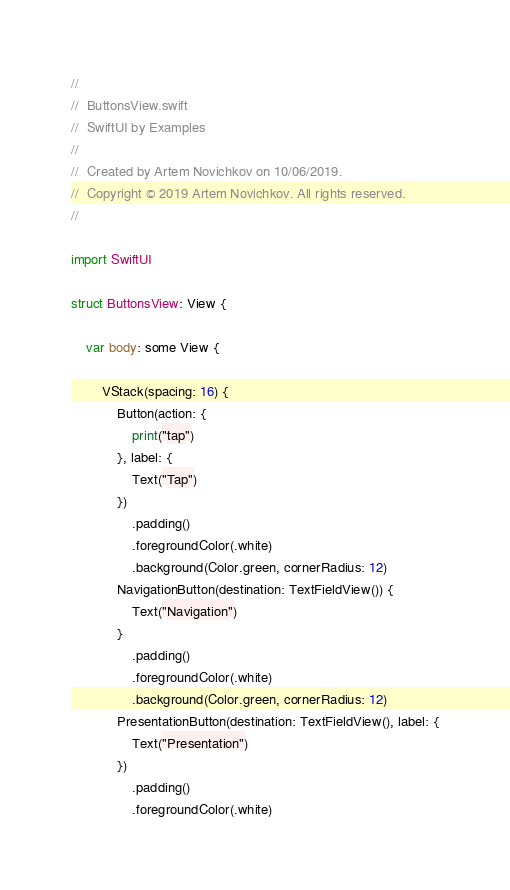Convert code to text. <code><loc_0><loc_0><loc_500><loc_500><_Swift_>//
//  ButtonsView.swift
//  SwiftUI by Examples
//
//  Created by Artem Novichkov on 10/06/2019.
//  Copyright © 2019 Artem Novichkov. All rights reserved.
//

import SwiftUI

struct ButtonsView: View {

    var body: some View {

        VStack(spacing: 16) {
            Button(action: {
                print("tap")
            }, label: {
                Text("Tap")
            })
                .padding()
                .foregroundColor(.white)
                .background(Color.green, cornerRadius: 12)
            NavigationButton(destination: TextFieldView()) {
                Text("Navigation")
            }
                .padding()
                .foregroundColor(.white)
                .background(Color.green, cornerRadius: 12)
            PresentationButton(destination: TextFieldView(), label: {
                Text("Presentation")
            })
                .padding()
                .foregroundColor(.white)</code> 